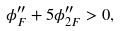Convert formula to latex. <formula><loc_0><loc_0><loc_500><loc_500>\phi ^ { \prime \prime } _ { F } + 5 \phi ^ { \prime \prime } _ { 2 F } > 0 ,</formula> 